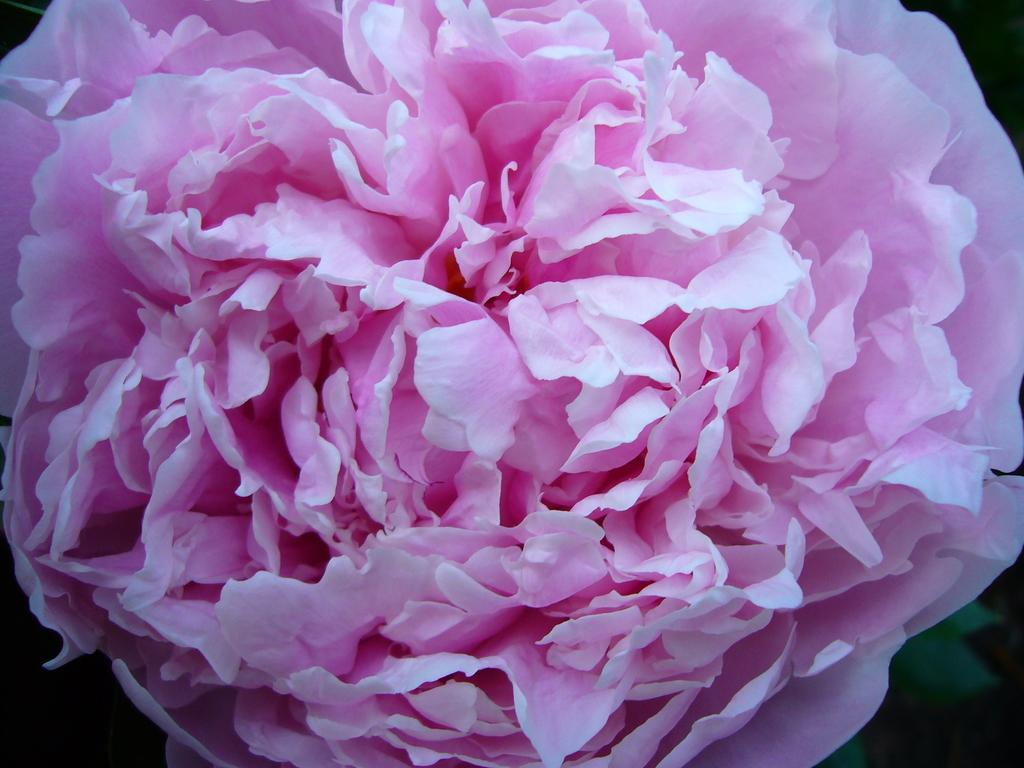What is the main subject of the picture? The main subject of the picture is a flower. What color is the flower? The flower is pink in color. How many petals does the flower have? The flower has many petals. What is located under the flower? There is a leaf under the flower. What is the size of the shock that the flower is experiencing in the image? There is no shock present in the image, and therefore no size can be determined. 